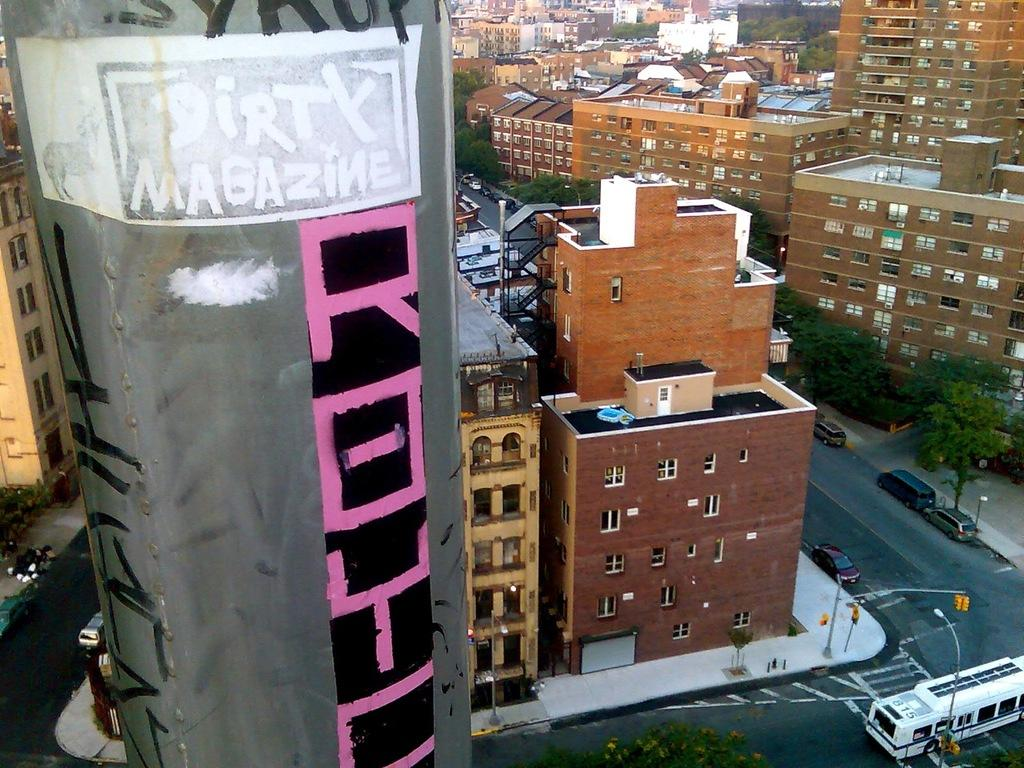What can be seen on the road in the image? There are vehicles on the road in the image. What structures are present in the image? There are poles, lights, buildings, and trees in the image. What type of thread is being used to hang the wax from the trees in the image? There is no thread or wax present in the image; it features vehicles on the road, poles, lights, buildings, and trees. 